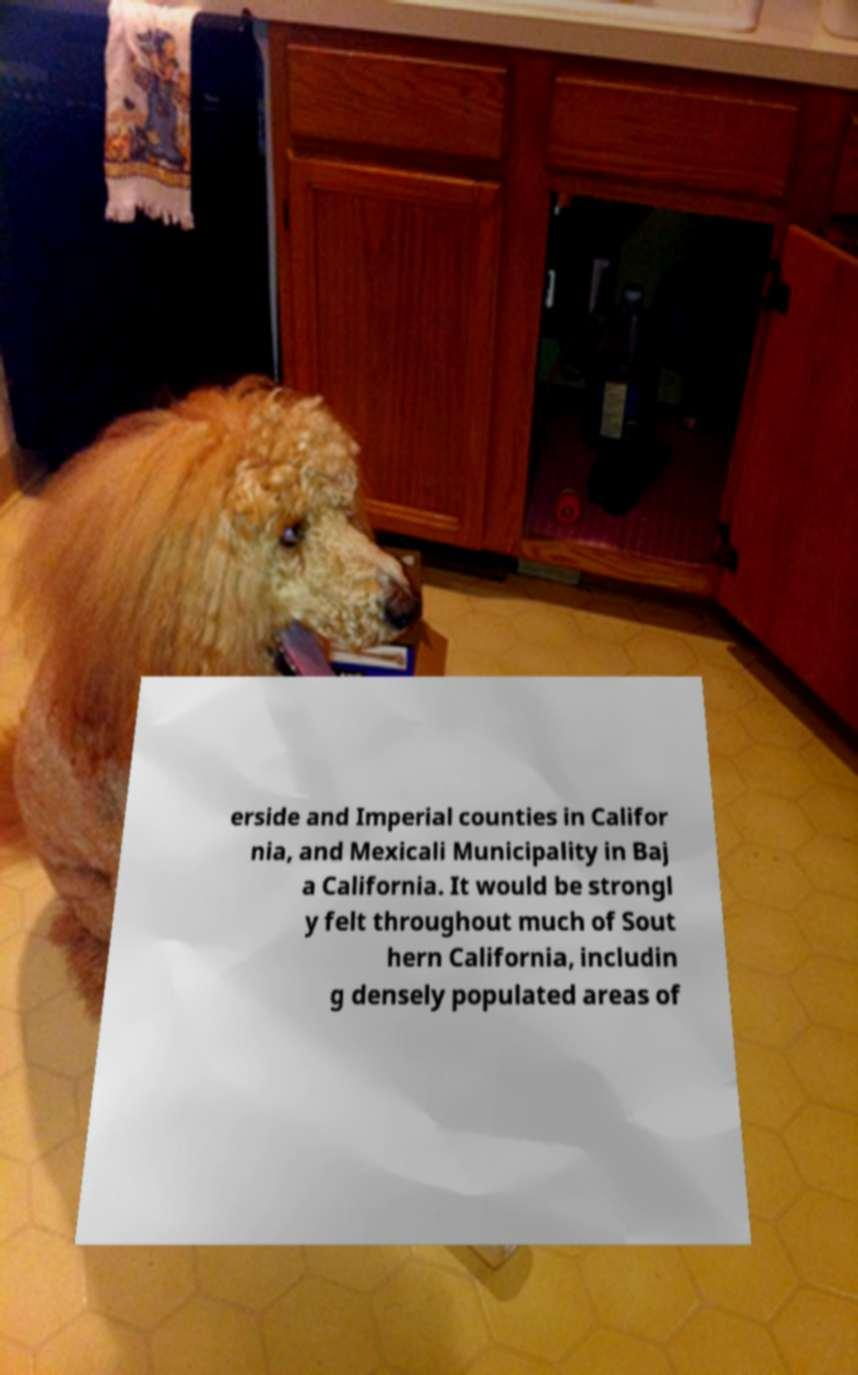I need the written content from this picture converted into text. Can you do that? erside and Imperial counties in Califor nia, and Mexicali Municipality in Baj a California. It would be strongl y felt throughout much of Sout hern California, includin g densely populated areas of 